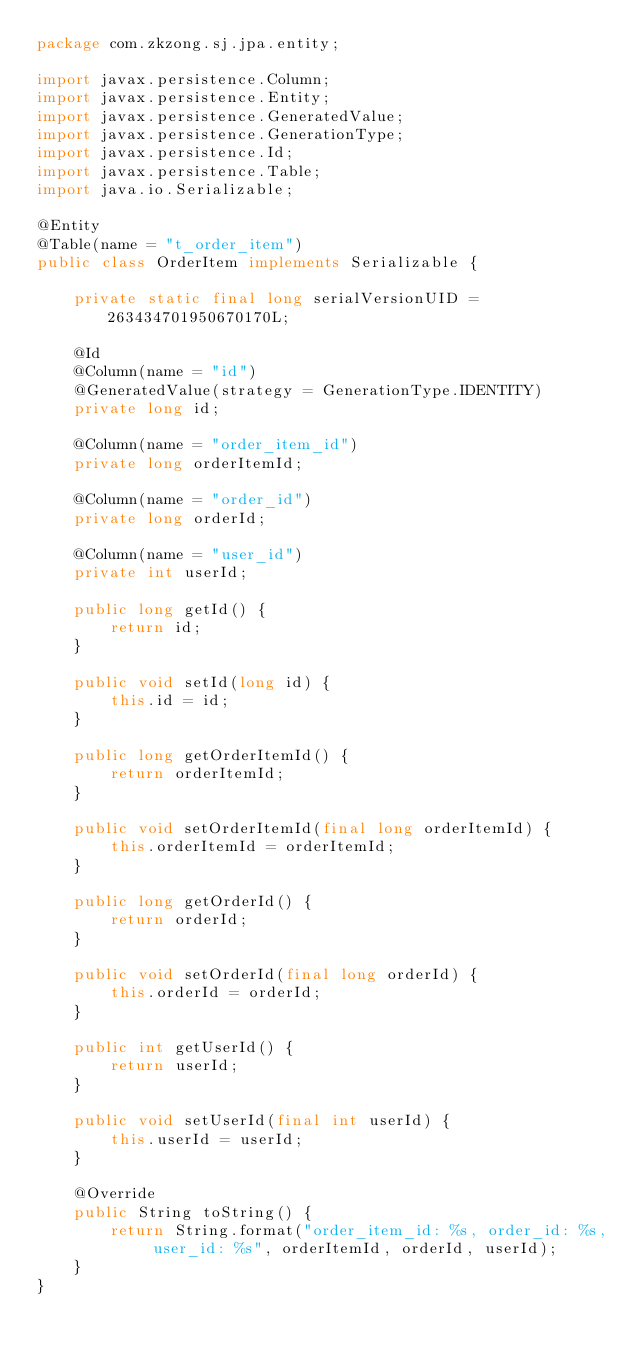Convert code to text. <code><loc_0><loc_0><loc_500><loc_500><_Java_>package com.zkzong.sj.jpa.entity;

import javax.persistence.Column;
import javax.persistence.Entity;
import javax.persistence.GeneratedValue;
import javax.persistence.GenerationType;
import javax.persistence.Id;
import javax.persistence.Table;
import java.io.Serializable;

@Entity
@Table(name = "t_order_item")
public class OrderItem implements Serializable {

    private static final long serialVersionUID = 263434701950670170L;

    @Id
    @Column(name = "id")
    @GeneratedValue(strategy = GenerationType.IDENTITY)
    private long id;

    @Column(name = "order_item_id")
    private long orderItemId;

    @Column(name = "order_id")
    private long orderId;

    @Column(name = "user_id")
    private int userId;

    public long getId() {
        return id;
    }

    public void setId(long id) {
        this.id = id;
    }

    public long getOrderItemId() {
        return orderItemId;
    }

    public void setOrderItemId(final long orderItemId) {
        this.orderItemId = orderItemId;
    }

    public long getOrderId() {
        return orderId;
    }

    public void setOrderId(final long orderId) {
        this.orderId = orderId;
    }

    public int getUserId() {
        return userId;
    }

    public void setUserId(final int userId) {
        this.userId = userId;
    }

    @Override
    public String toString() {
        return String.format("order_item_id: %s, order_id: %s, user_id: %s", orderItemId, orderId, userId);
    }
}
</code> 